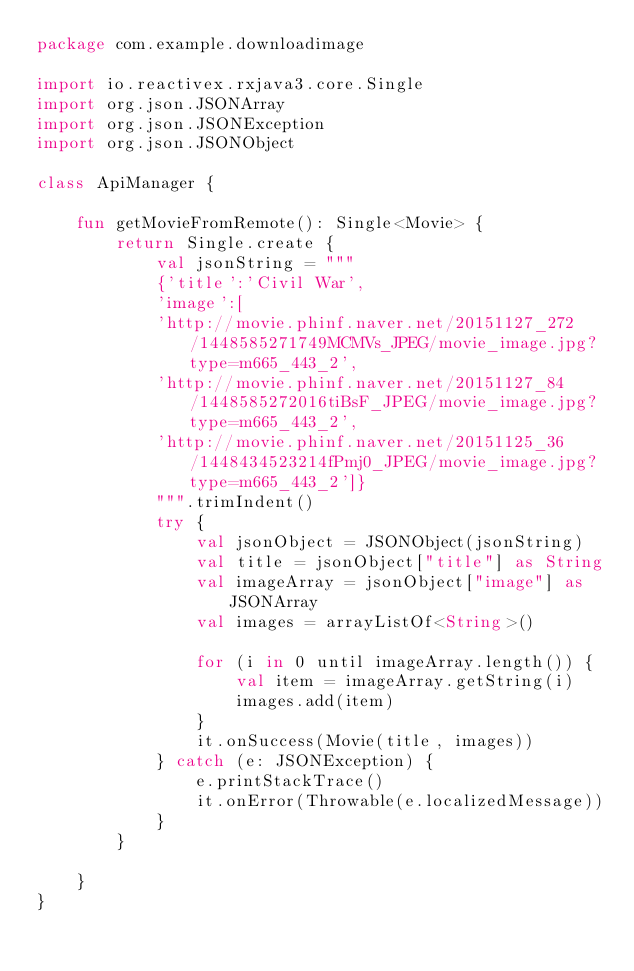Convert code to text. <code><loc_0><loc_0><loc_500><loc_500><_Kotlin_>package com.example.downloadimage

import io.reactivex.rxjava3.core.Single
import org.json.JSONArray
import org.json.JSONException
import org.json.JSONObject

class ApiManager {

    fun getMovieFromRemote(): Single<Movie> {
        return Single.create {
            val jsonString = """
            {'title':'Civil War',
            'image':[
            'http://movie.phinf.naver.net/20151127_272/1448585271749MCMVs_JPEG/movie_image.jpg?type=m665_443_2',
            'http://movie.phinf.naver.net/20151127_84/1448585272016tiBsF_JPEG/movie_image.jpg?type=m665_443_2',
            'http://movie.phinf.naver.net/20151125_36/1448434523214fPmj0_JPEG/movie_image.jpg?type=m665_443_2']}
            """.trimIndent()
            try {
                val jsonObject = JSONObject(jsonString)
                val title = jsonObject["title"] as String
                val imageArray = jsonObject["image"] as JSONArray
                val images = arrayListOf<String>()

                for (i in 0 until imageArray.length()) {
                    val item = imageArray.getString(i)
                    images.add(item)
                }
                it.onSuccess(Movie(title, images))
            } catch (e: JSONException) {
                e.printStackTrace()
                it.onError(Throwable(e.localizedMessage))
            }
        }

    }
}</code> 